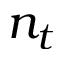<formula> <loc_0><loc_0><loc_500><loc_500>n _ { t }</formula> 